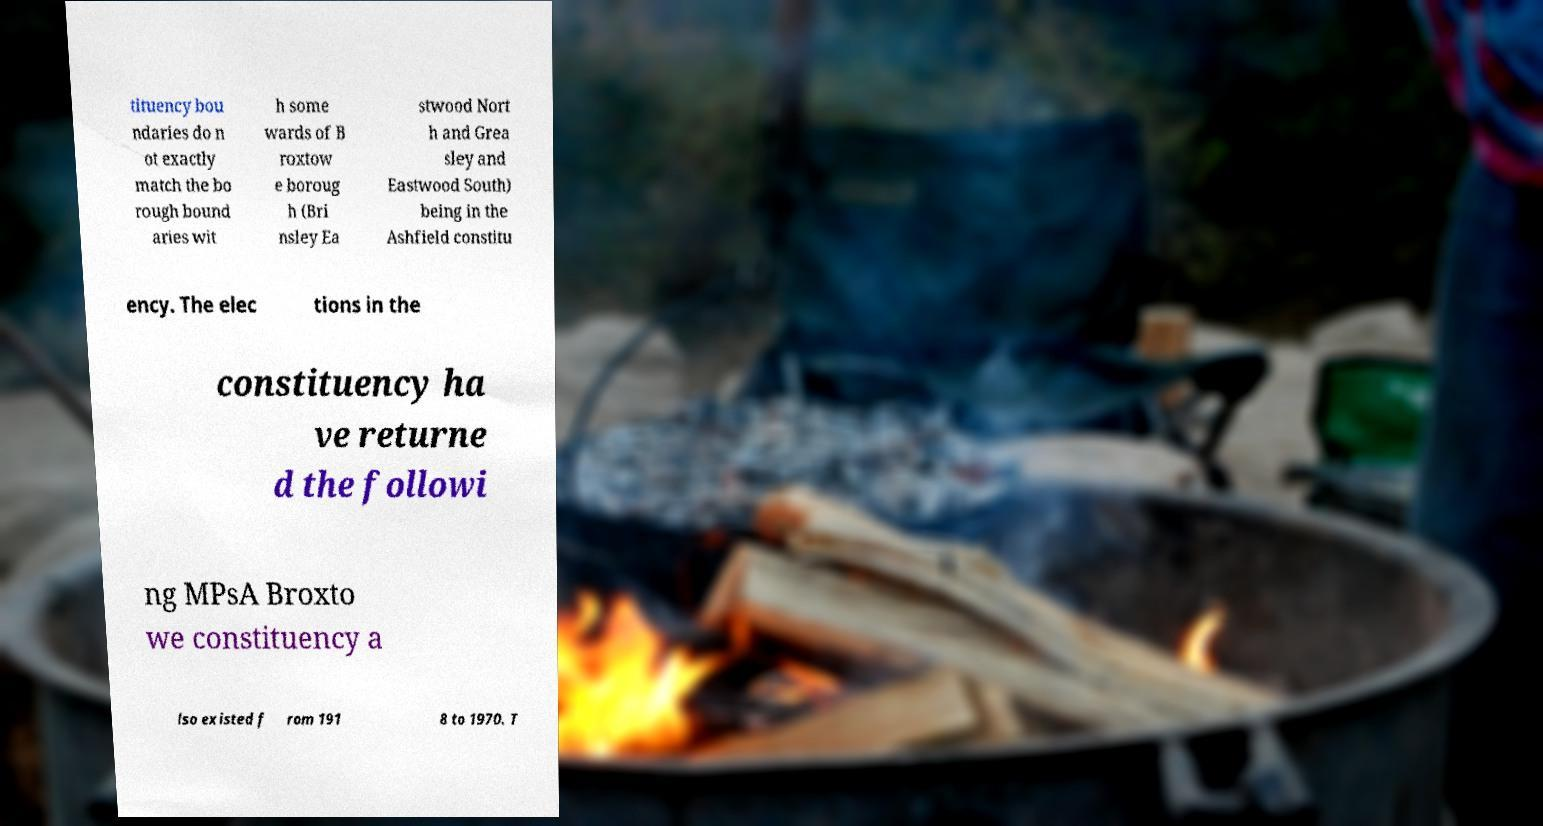For documentation purposes, I need the text within this image transcribed. Could you provide that? tituency bou ndaries do n ot exactly match the bo rough bound aries wit h some wards of B roxtow e boroug h (Bri nsley Ea stwood Nort h and Grea sley and Eastwood South) being in the Ashfield constitu ency. The elec tions in the constituency ha ve returne d the followi ng MPsA Broxto we constituency a lso existed f rom 191 8 to 1970. T 